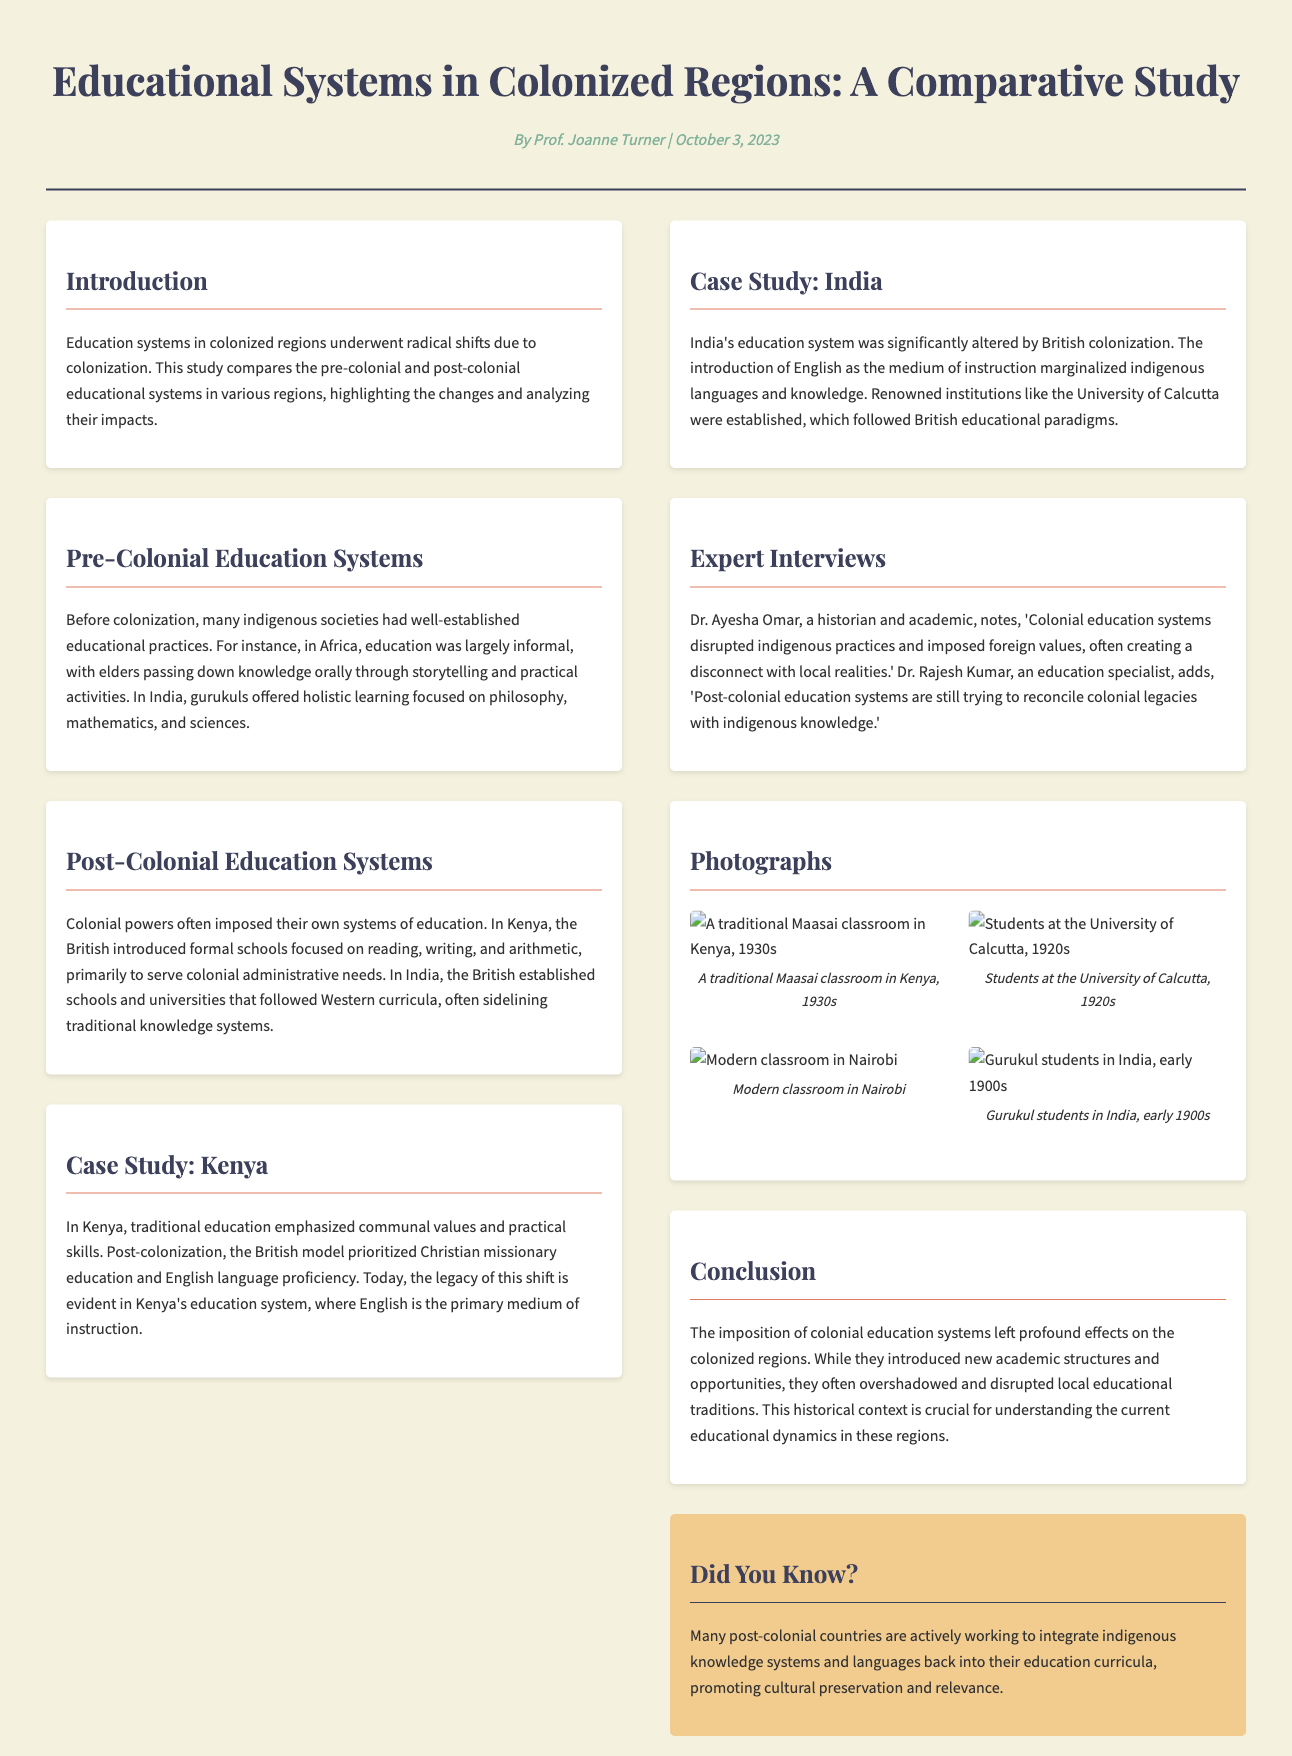What is the title of the document? The title is presented prominently at the top of the document, highlighting the focus on education systems in colonized regions.
Answer: Educational Systems in Colonized Regions: A Comparative Study Who is the author of the document? The author is noted below the title, indicating who wrote the piece.
Answer: Prof. Joanne Turner What date was the document published? The publication date is included alongside the author’s name to provide context for the timing of the document.
Answer: October 3, 2023 What region is highlighted in the case study section about modern education? The document discusses a specific region and its educational evolution in the case studies section.
Answer: Kenya What language was primarily used in British schools in India post-colonization? The document points out a significant change in the medium of instruction during British colonization in India.
Answer: English Which educational practice is featured in the traditional Maasai classroom photo? The photo description provides insight into the educational practices from a historical perspective.
Answer: Traditional Maasai classroom What significant shift occurred in education systems post-colonization according to Dr. Ayesha Omar? The expert interview sections provide insights into the impacts of colonial education on indigenous practices.
Answer: Disrupted indigenous practices What is a key characteristic of education prior to colonization in Africa? The document describes earlier educational systems emphasizing traditional methods before colonial influences.
Answer: Informal What does the sidebar mention about post-colonial countries? The sidebar provides an interesting fact that highlights efforts related to educational curricula in post-colonial contexts.
Answer: Integrate indigenous knowledge systems and languages 